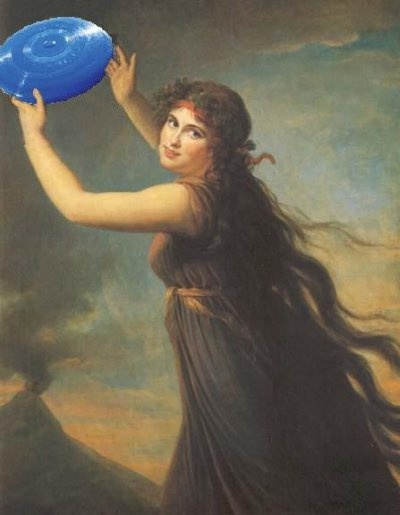Describe the objects in this image and their specific colors. I can see people in gray and black tones and frisbee in gray, blue, and darkblue tones in this image. 